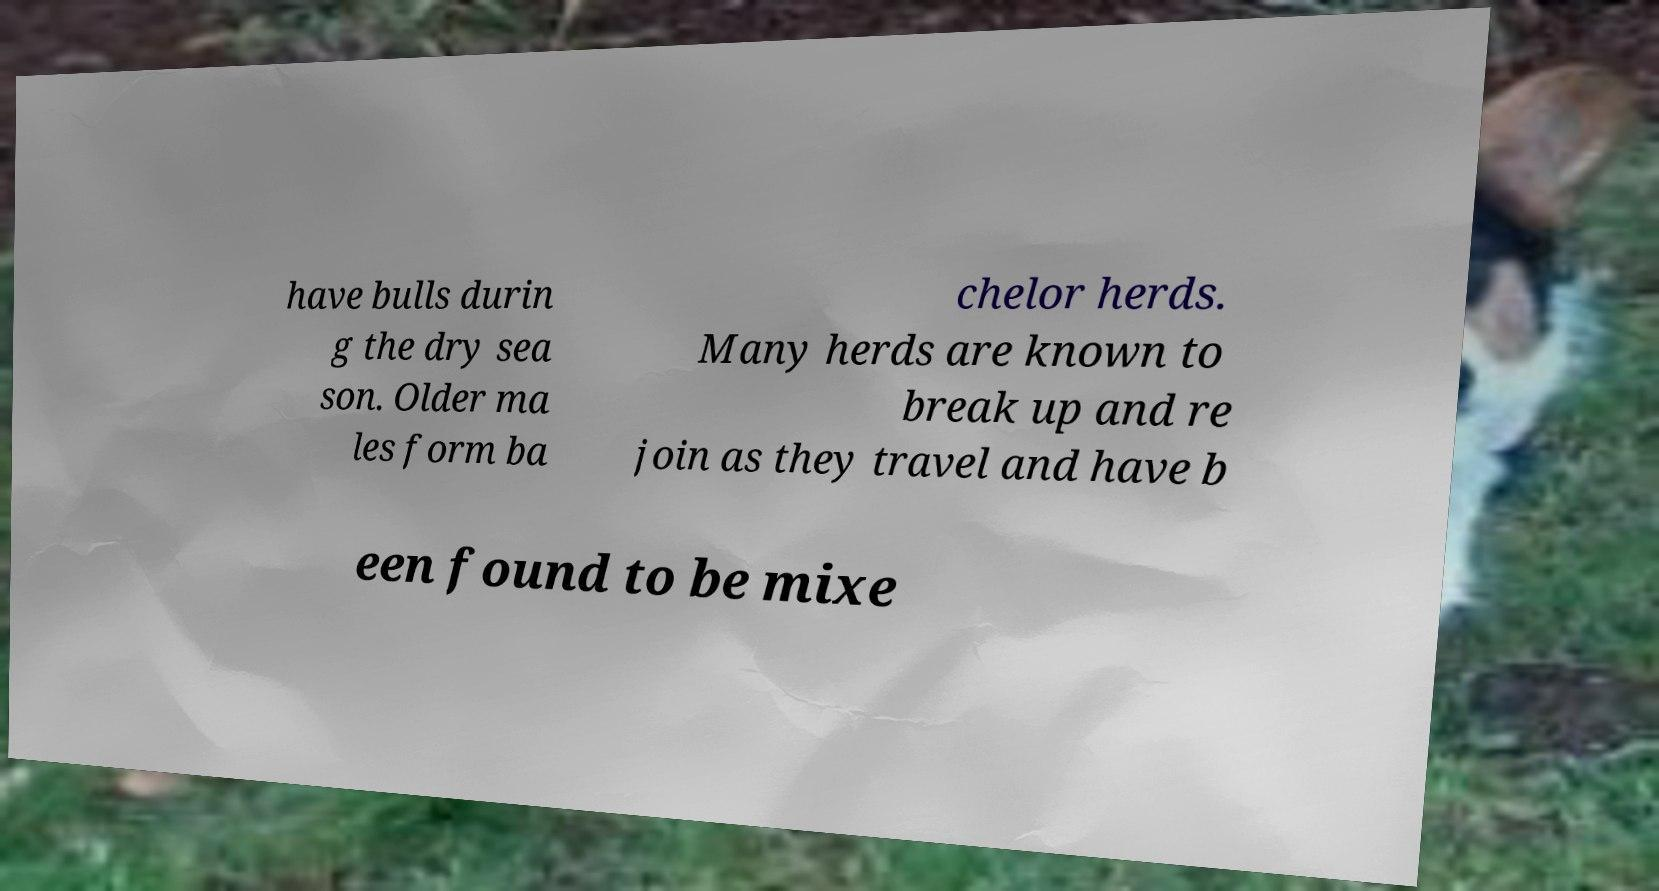Could you assist in decoding the text presented in this image and type it out clearly? have bulls durin g the dry sea son. Older ma les form ba chelor herds. Many herds are known to break up and re join as they travel and have b een found to be mixe 